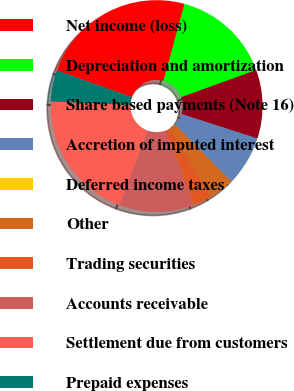<chart> <loc_0><loc_0><loc_500><loc_500><pie_chart><fcel>Net income (loss)<fcel>Depreciation and amortization<fcel>Share based payments (Note 16)<fcel>Accretion of imputed interest<fcel>Deferred income taxes<fcel>Other<fcel>Trading securities<fcel>Accounts receivable<fcel>Settlement due from customers<fcel>Prepaid expenses<nl><fcel>23.79%<fcel>15.23%<fcel>10.48%<fcel>7.62%<fcel>0.01%<fcel>3.82%<fcel>2.87%<fcel>11.43%<fcel>19.99%<fcel>4.77%<nl></chart> 